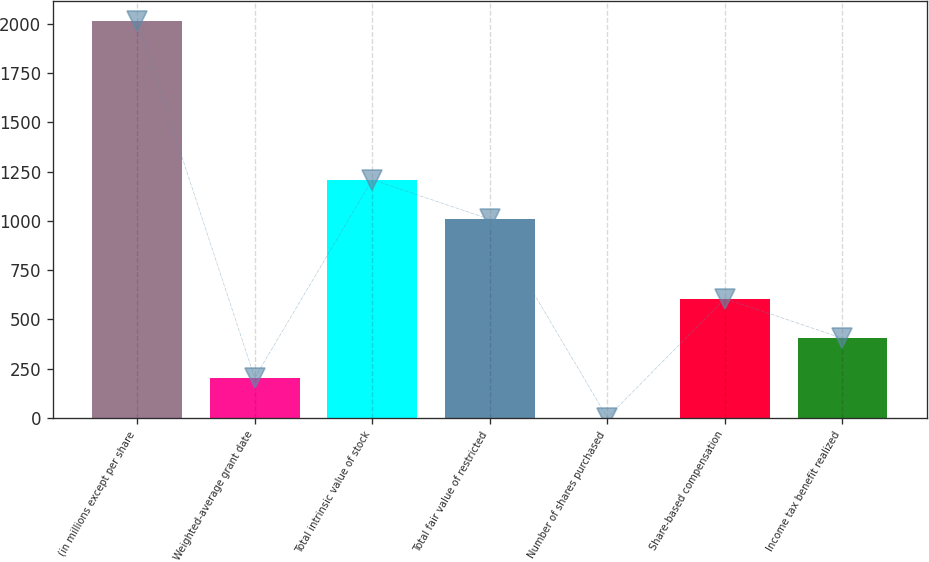<chart> <loc_0><loc_0><loc_500><loc_500><bar_chart><fcel>(in millions except per share<fcel>Weighted-average grant date<fcel>Total intrinsic value of stock<fcel>Total fair value of restricted<fcel>Number of shares purchased<fcel>Share-based compensation<fcel>Income tax benefit realized<nl><fcel>2015<fcel>203.3<fcel>1209.8<fcel>1008.5<fcel>2<fcel>605.9<fcel>404.6<nl></chart> 